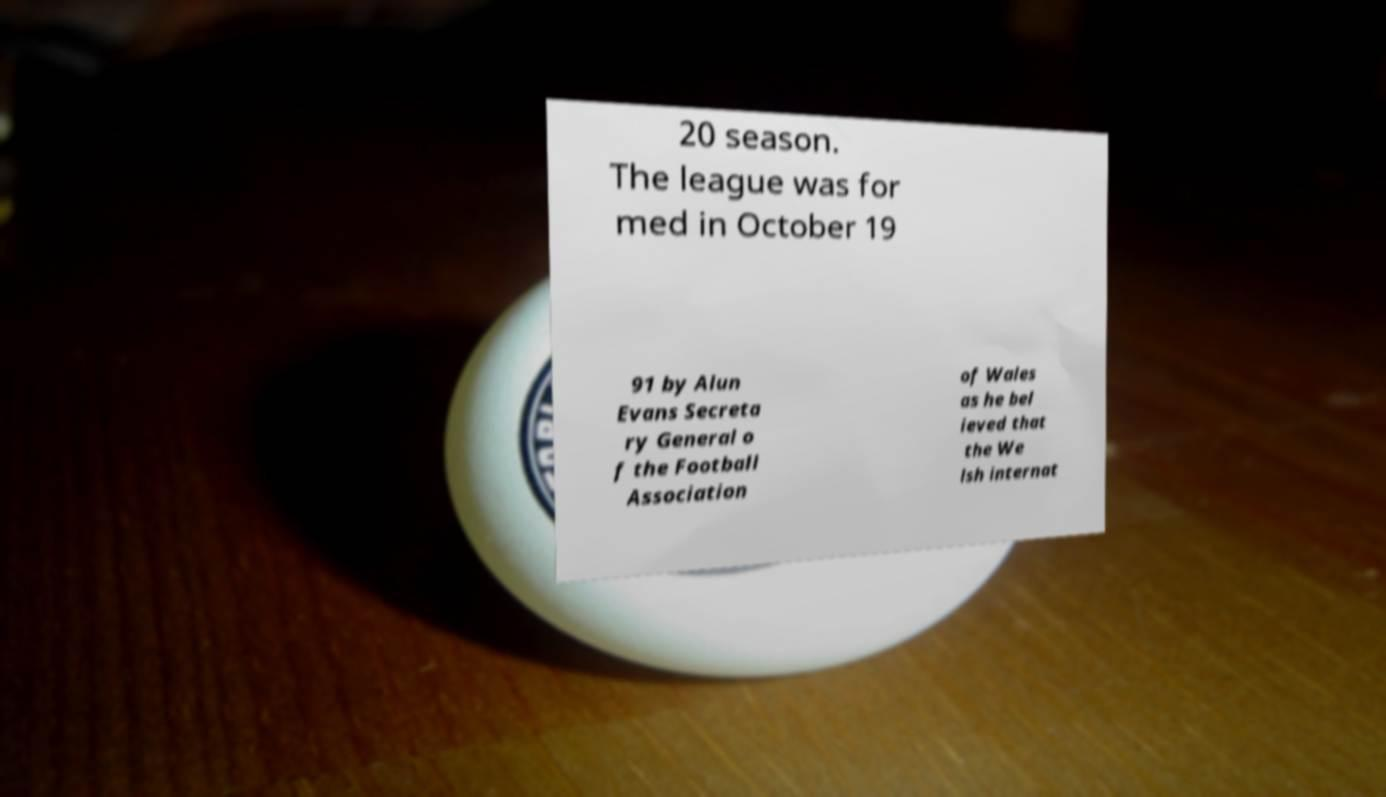What messages or text are displayed in this image? I need them in a readable, typed format. 20 season. The league was for med in October 19 91 by Alun Evans Secreta ry General o f the Football Association of Wales as he bel ieved that the We lsh internat 